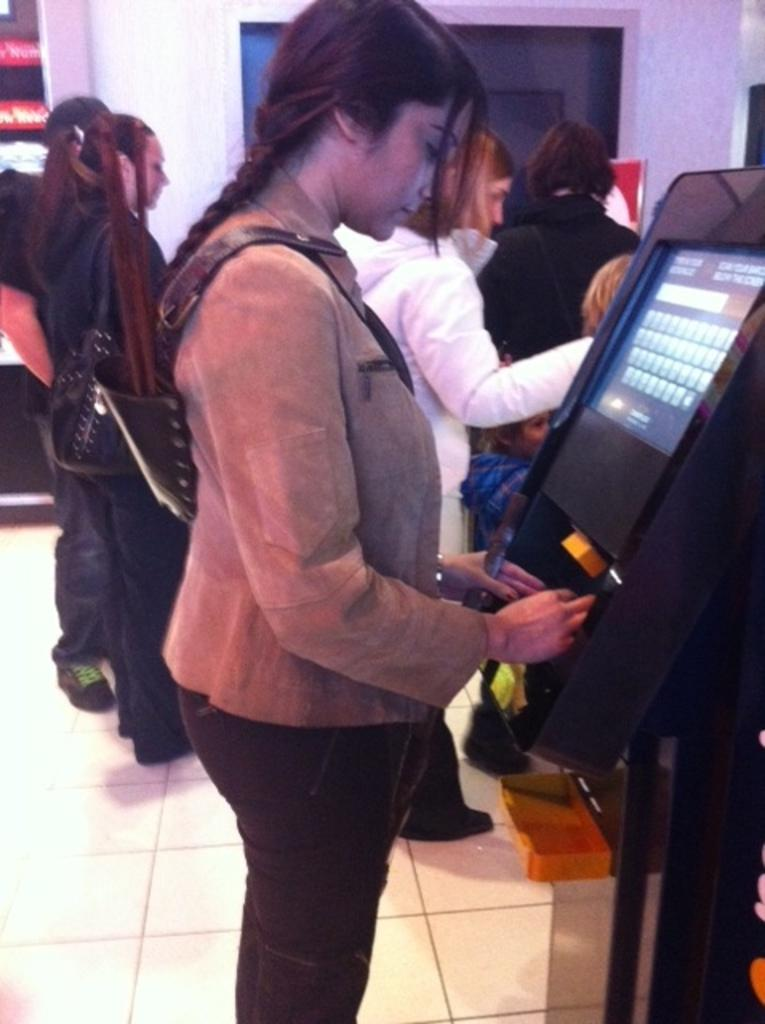Who is the main subject in the foreground of the image? There is a woman standing in the foreground of the image. What is the woman doing in the image? The woman is in front of a machine. Can you describe the background of the image? There are people, a door, and some objects in the background of the image. What color is the quiet point in the image? There is no quiet point or color mentioned in the image; it features a woman standing in front of a machine with people and objects in the background. 